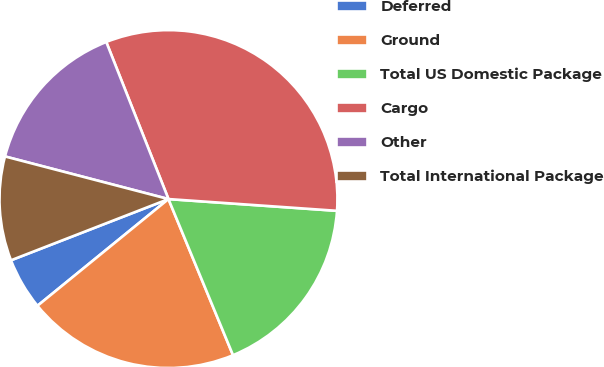<chart> <loc_0><loc_0><loc_500><loc_500><pie_chart><fcel>Deferred<fcel>Ground<fcel>Total US Domestic Package<fcel>Cargo<fcel>Other<fcel>Total International Package<nl><fcel>4.98%<fcel>20.36%<fcel>17.65%<fcel>32.11%<fcel>14.94%<fcel>9.96%<nl></chart> 